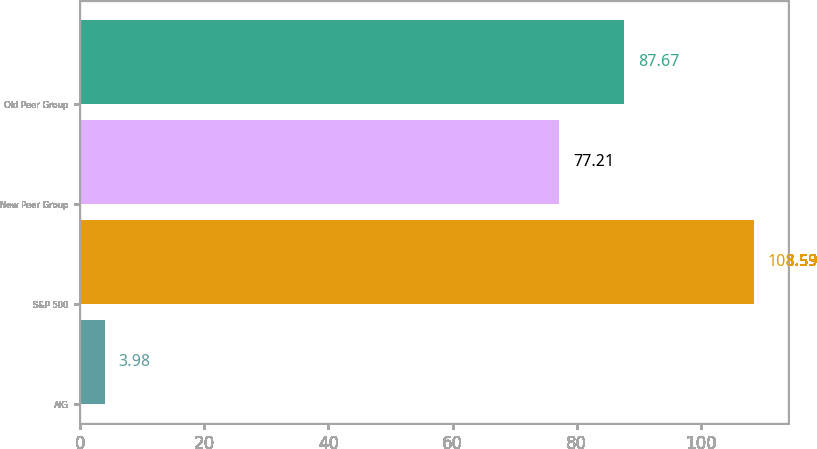Convert chart. <chart><loc_0><loc_0><loc_500><loc_500><bar_chart><fcel>AIG<fcel>S&P 500<fcel>New Peer Group<fcel>Old Peer Group<nl><fcel>3.98<fcel>108.59<fcel>77.21<fcel>87.67<nl></chart> 